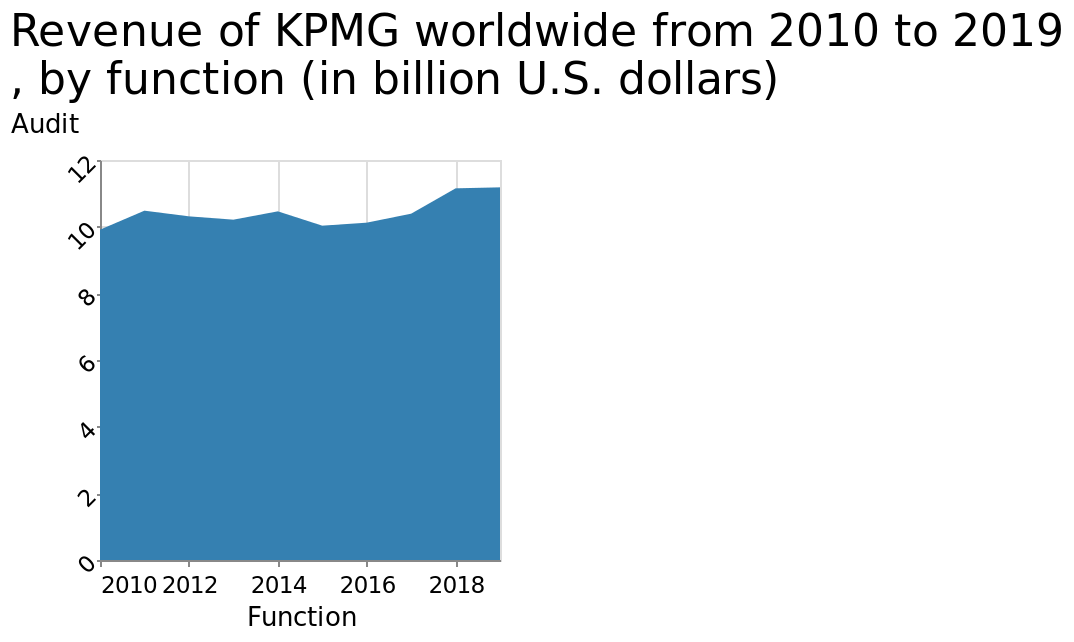<image>
Offer a thorough analysis of the image. The revenue of KPMG as stayed pretty even for the last 9 years. What is the range of the x-axis in the area plot? The range of the x-axis in the area plot is from 2010 to 2018. 